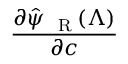<formula> <loc_0><loc_0><loc_500><loc_500>\frac { \partial \hat { \psi } _ { R } ( \Lambda ) } { \partial { c } }</formula> 